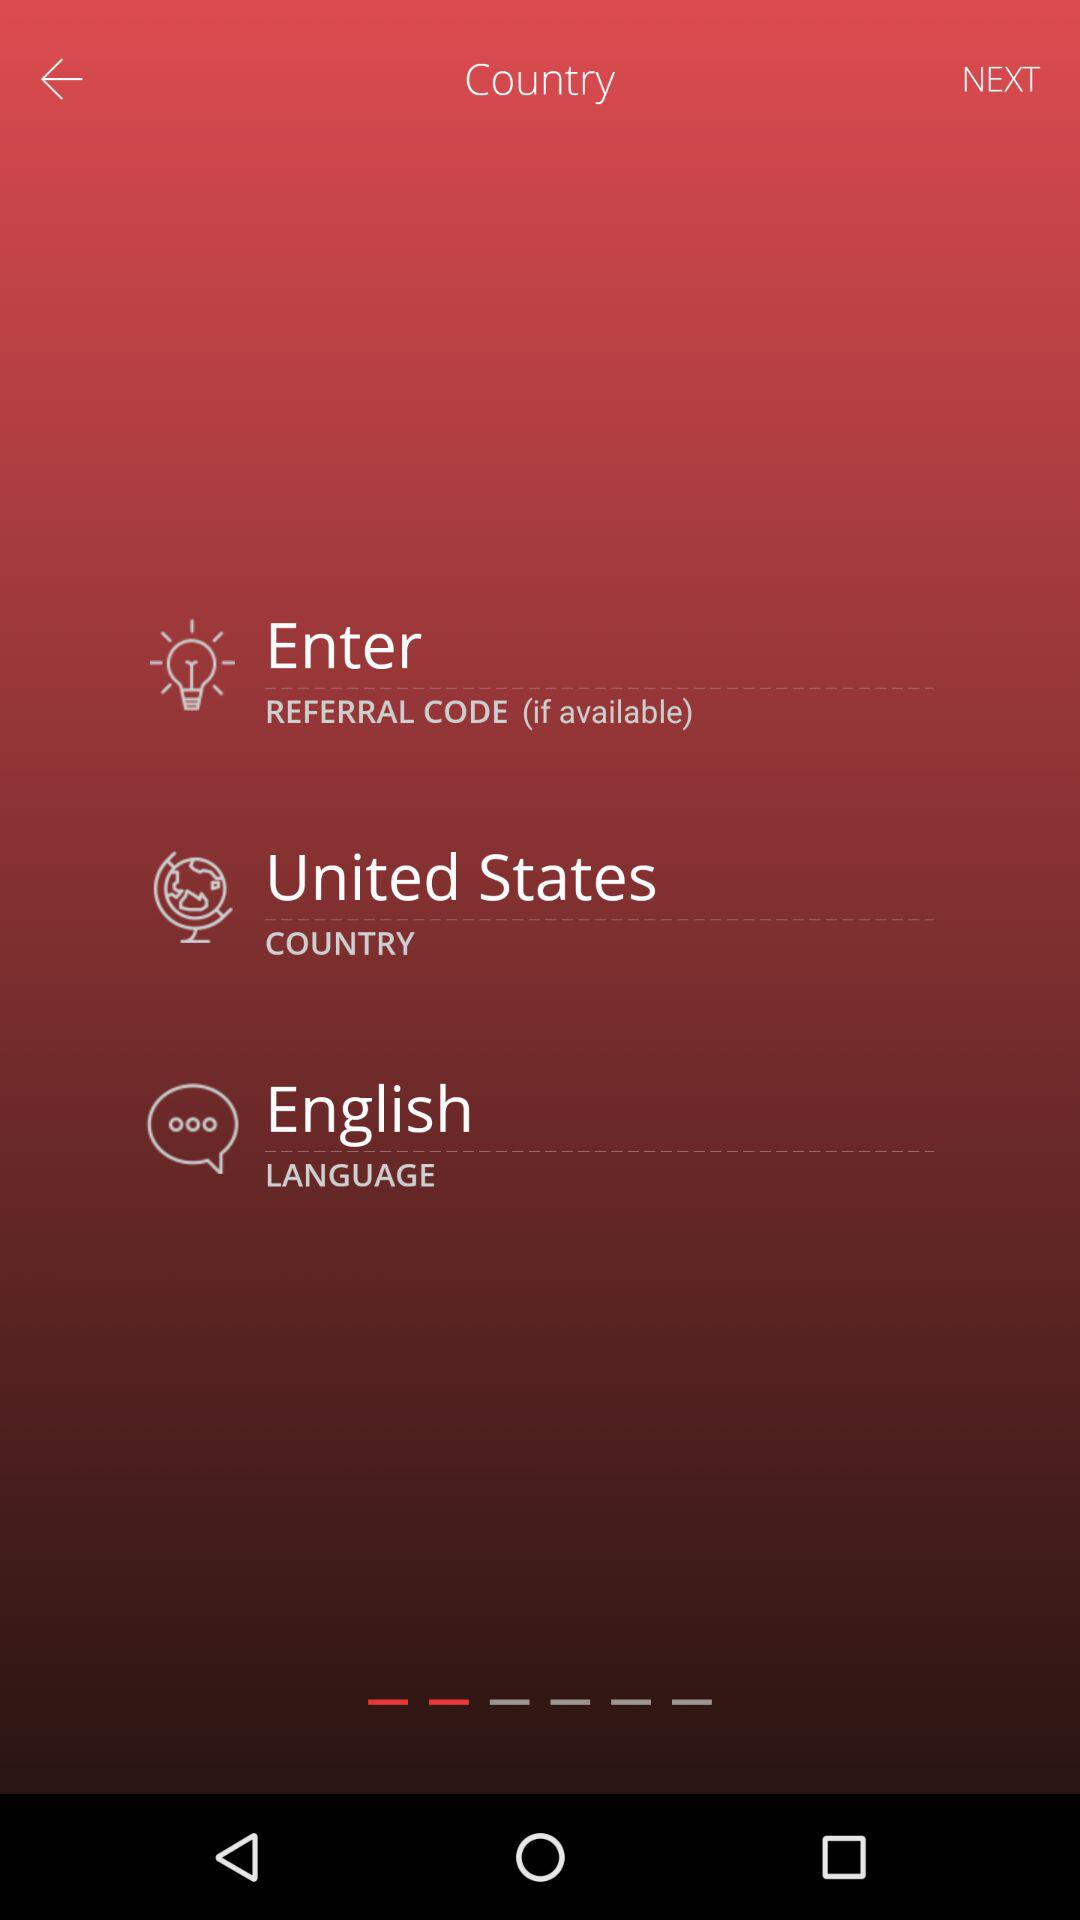What is the selected country? The selected country is the United States. 